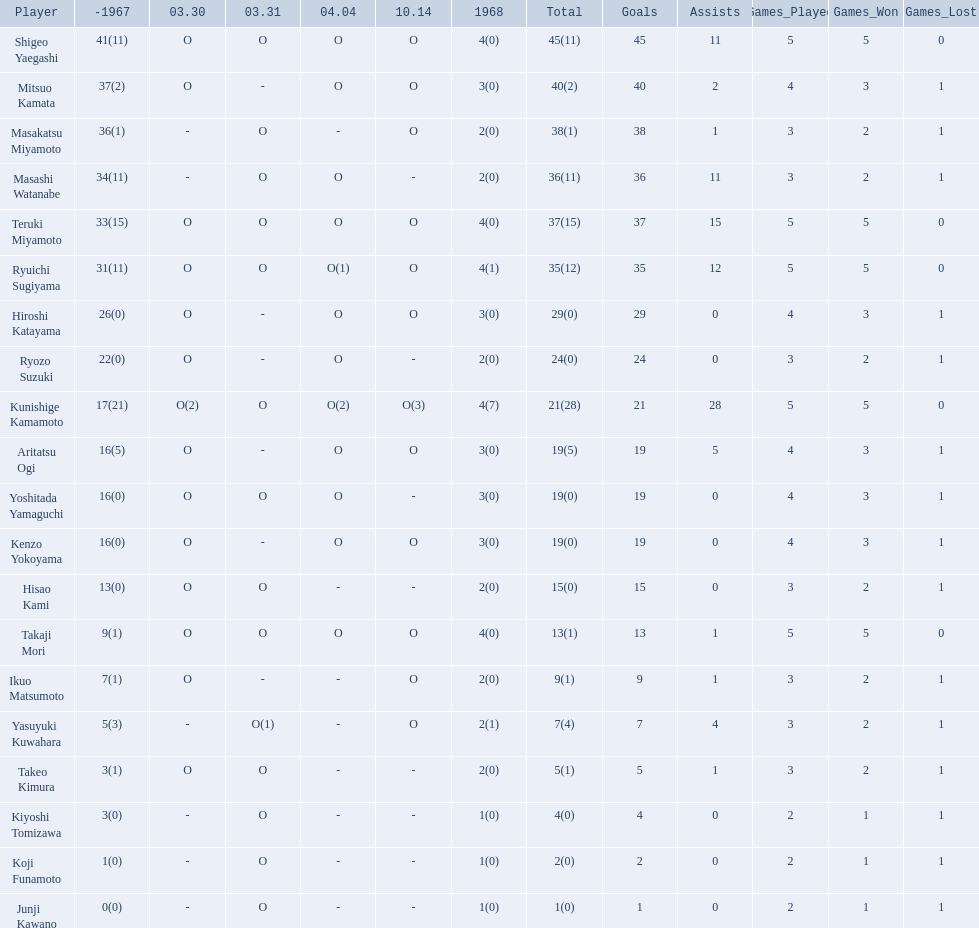Who were the players in the 1968 japanese football? Shigeo Yaegashi, Mitsuo Kamata, Masakatsu Miyamoto, Masashi Watanabe, Teruki Miyamoto, Ryuichi Sugiyama, Hiroshi Katayama, Ryozo Suzuki, Kunishige Kamamoto, Aritatsu Ogi, Yoshitada Yamaguchi, Kenzo Yokoyama, Hisao Kami, Takaji Mori, Ikuo Matsumoto, Yasuyuki Kuwahara, Takeo Kimura, Kiyoshi Tomizawa, Koji Funamoto, Junji Kawano. How many points total did takaji mori have? 13(1). How many points total did junju kawano? 1(0). Who had more points? Takaji Mori. 